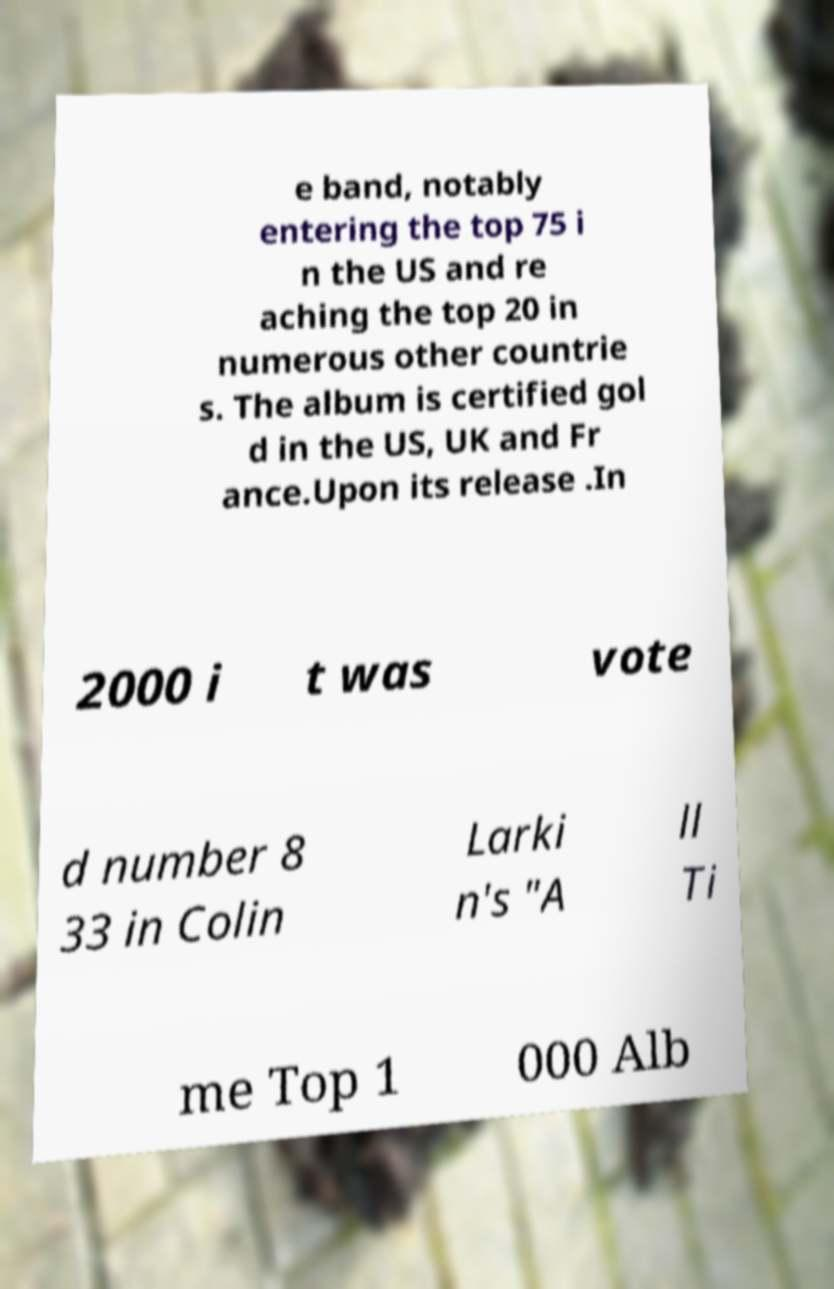Can you accurately transcribe the text from the provided image for me? e band, notably entering the top 75 i n the US and re aching the top 20 in numerous other countrie s. The album is certified gol d in the US, UK and Fr ance.Upon its release .In 2000 i t was vote d number 8 33 in Colin Larki n's "A ll Ti me Top 1 000 Alb 